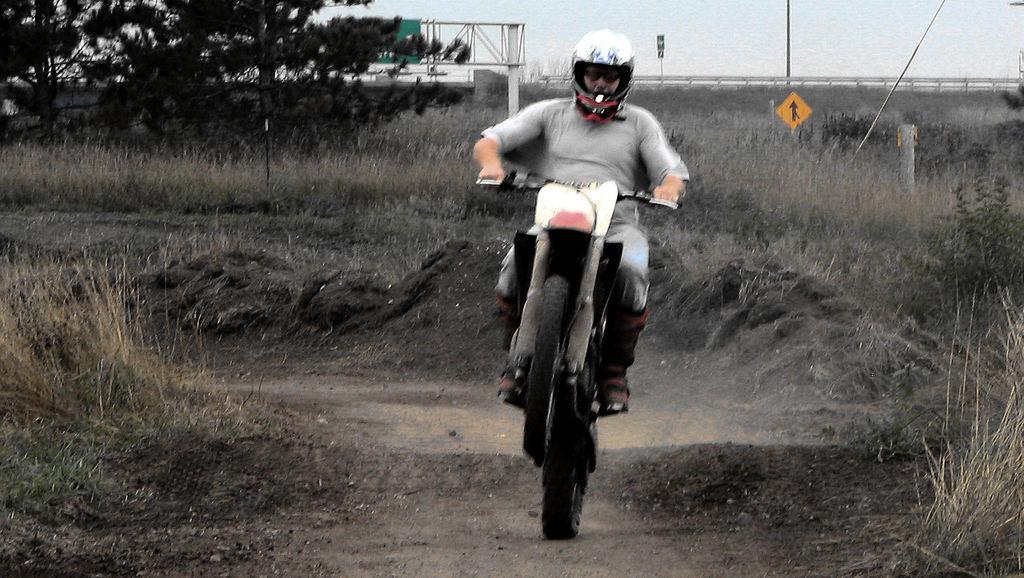Describe this image in one or two sentences. In the picture we can see a person wearing ash color T-shirt, helmet riding motorcycle and doing wheelie and in the background of the picture there are some trees, wording and clear sky. 